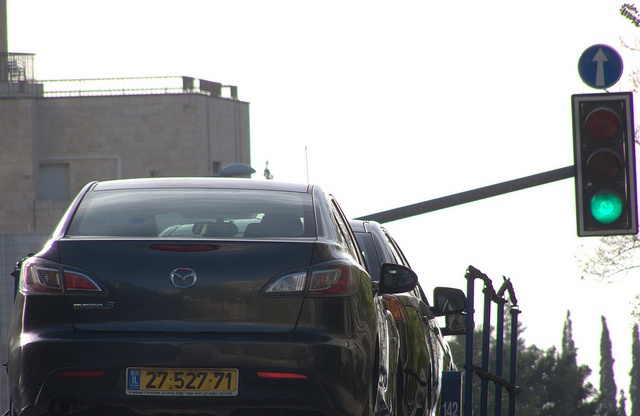Describe the objects in this image and their specific colors. I can see car in gray, black, and darkgray tones, traffic light in gray, black, navy, and purple tones, and car in gray, black, darkgray, and darkgreen tones in this image. 